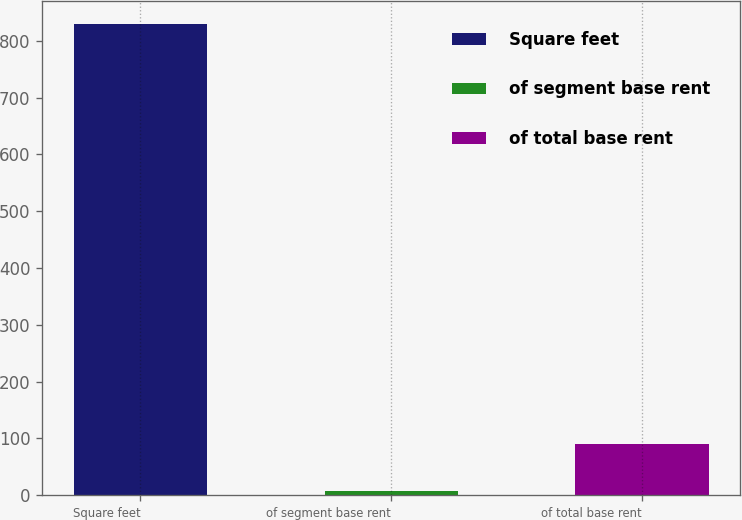<chart> <loc_0><loc_0><loc_500><loc_500><bar_chart><fcel>Square feet<fcel>of segment base rent<fcel>of total base rent<nl><fcel>829<fcel>8<fcel>90.1<nl></chart> 